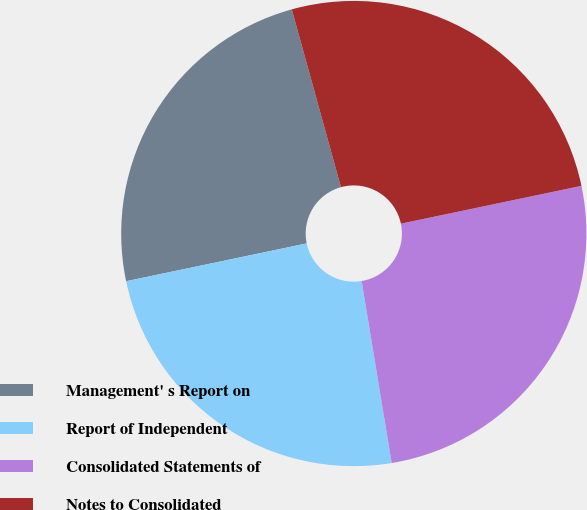Convert chart. <chart><loc_0><loc_0><loc_500><loc_500><pie_chart><fcel>Management' s Report on<fcel>Report of Independent<fcel>Consolidated Statements of<fcel>Notes to Consolidated<nl><fcel>23.99%<fcel>24.32%<fcel>25.68%<fcel>26.01%<nl></chart> 